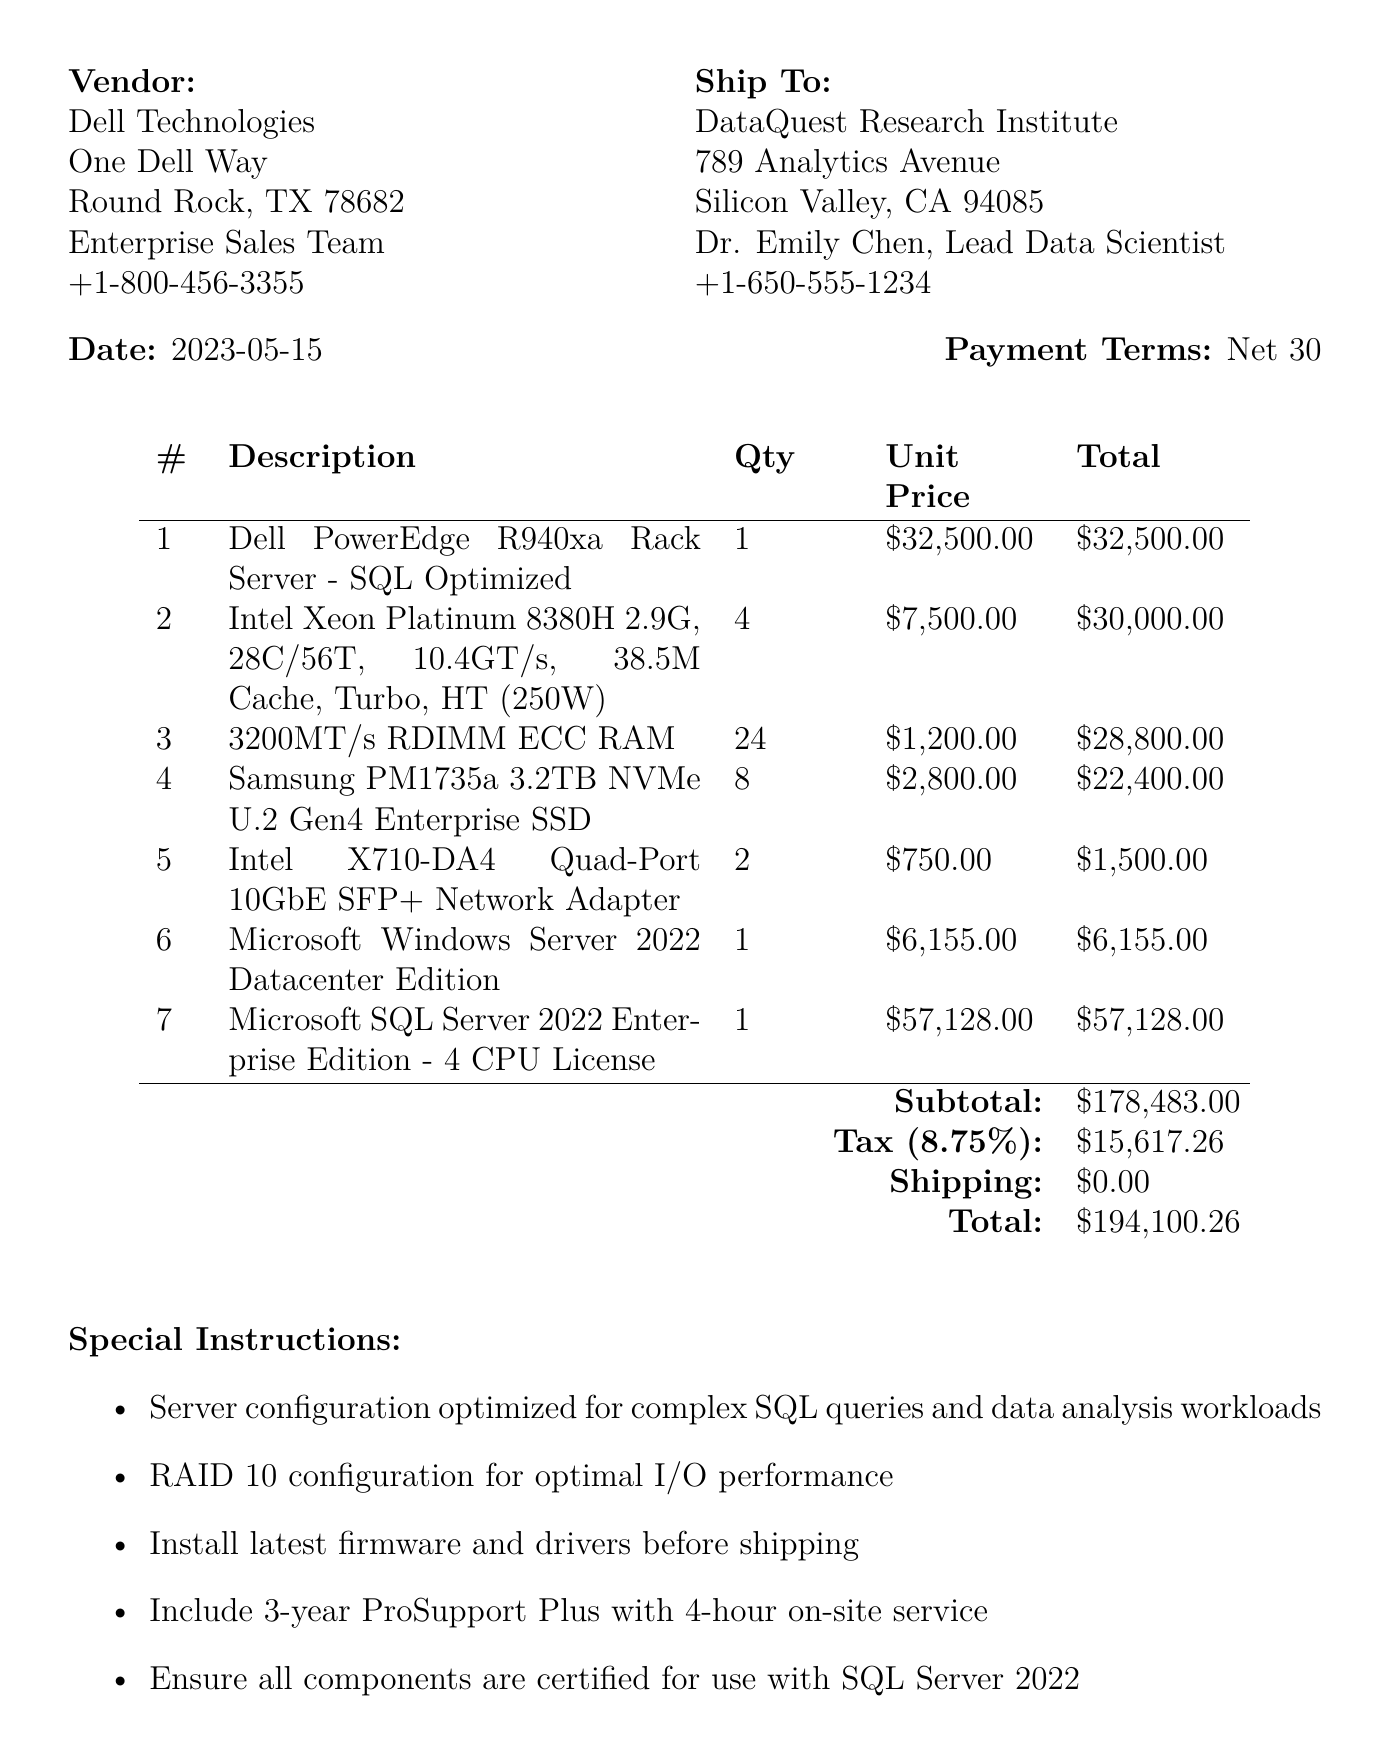What is the order number? The order number is a specific identifier for the Purchase Order, found in the document.
Answer: PO-23456-DBSVR Who is the vendor? The vendor's name is listed in the document as the company supplying the items.
Answer: Dell Technologies What is the subtotal amount? The subtotal amount is the total before taxes and shipping, provided in the summary section of the document.
Answer: $178,483.00 How many units of RAM are purchased? The quantity of RAM purchased is specified in the item list of the document.
Answer: 24 What is the tax rate applied? The tax rate is mentioned in the document as a percentage applied to the subtotal.
Answer: 8.75% What date was the purchase order approved by Dr. Emily Chen? The date of approval by Dr. Emily Chen is noted in the approvals section.
Answer: 2023-05-14 What special instruction is provided regarding RAID configuration? Special instructions are listed concerning the setup of the server for optimized performance.
Answer: RAID 10 configuration for optimal I/O performance What is the total payment amount? The total payment amount is presented at the end of the financial summary in the document.
Answer: $194,100.26 How many Intel Xeon processors are included in the order? The number of processors is specified in the item list alongside their description.
Answer: 4 